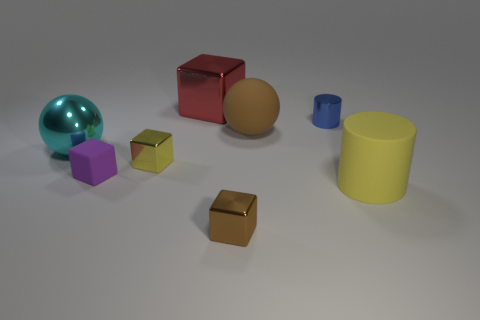What material is the block behind the large sphere that is to the left of the large red object?
Keep it short and to the point. Metal. What material is the object that is the same color as the rubber cylinder?
Provide a short and direct response. Metal. What is the shape of the yellow matte object that is the same size as the cyan object?
Your answer should be compact. Cylinder. There is a metallic object on the left side of the tiny purple matte object; is its shape the same as the big shiny thing that is behind the blue cylinder?
Ensure brevity in your answer.  No. How many other things are there of the same material as the large cyan ball?
Keep it short and to the point. 4. Is the material of the big ball that is on the left side of the brown shiny cube the same as the sphere that is to the right of the red metal thing?
Offer a terse response. No. What is the shape of the big yellow object that is made of the same material as the large brown object?
Provide a succinct answer. Cylinder. Is there anything else of the same color as the rubber cylinder?
Your response must be concise. Yes. What number of tiny yellow shiny blocks are there?
Your answer should be compact. 1. There is a big object that is both left of the tiny brown thing and right of the cyan shiny object; what shape is it?
Make the answer very short. Cube. 